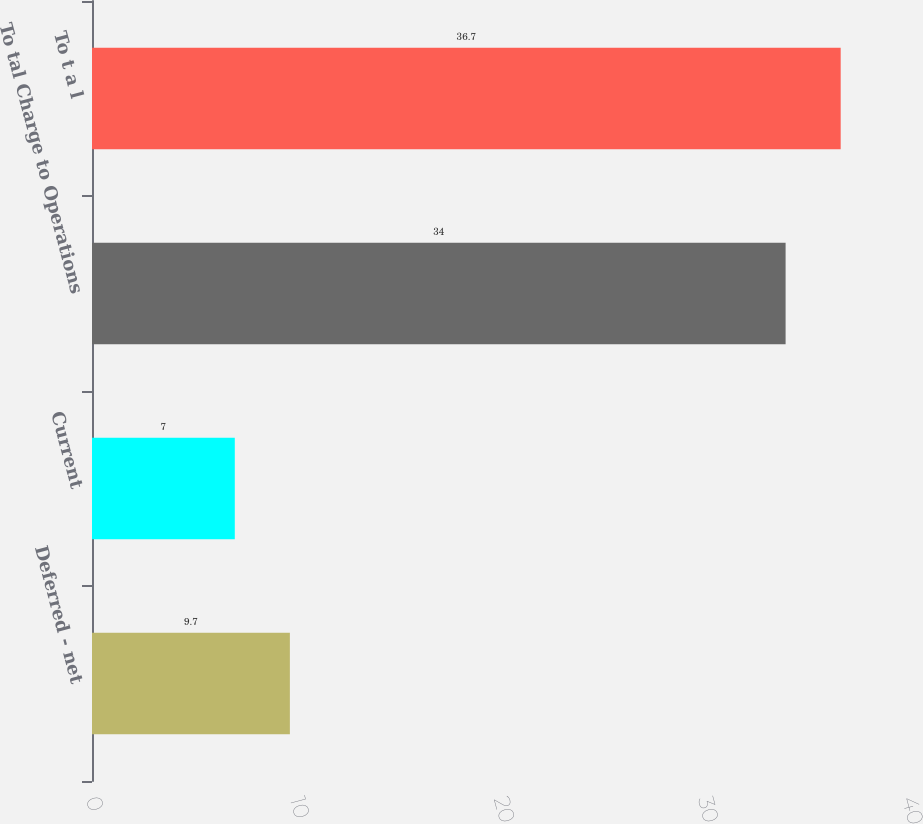Convert chart to OTSL. <chart><loc_0><loc_0><loc_500><loc_500><bar_chart><fcel>Deferred - net<fcel>Current<fcel>To tal Charge to Operations<fcel>To t a l<nl><fcel>9.7<fcel>7<fcel>34<fcel>36.7<nl></chart> 